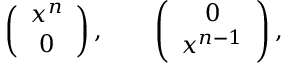<formula> <loc_0><loc_0><loc_500><loc_500>\left ( \begin{array} { c } { { x ^ { n } } } \\ { 0 } \end{array} \right ) , \quad \left ( \begin{array} { c } { 0 } \\ { { x ^ { n - 1 } } } \end{array} \right ) ,</formula> 